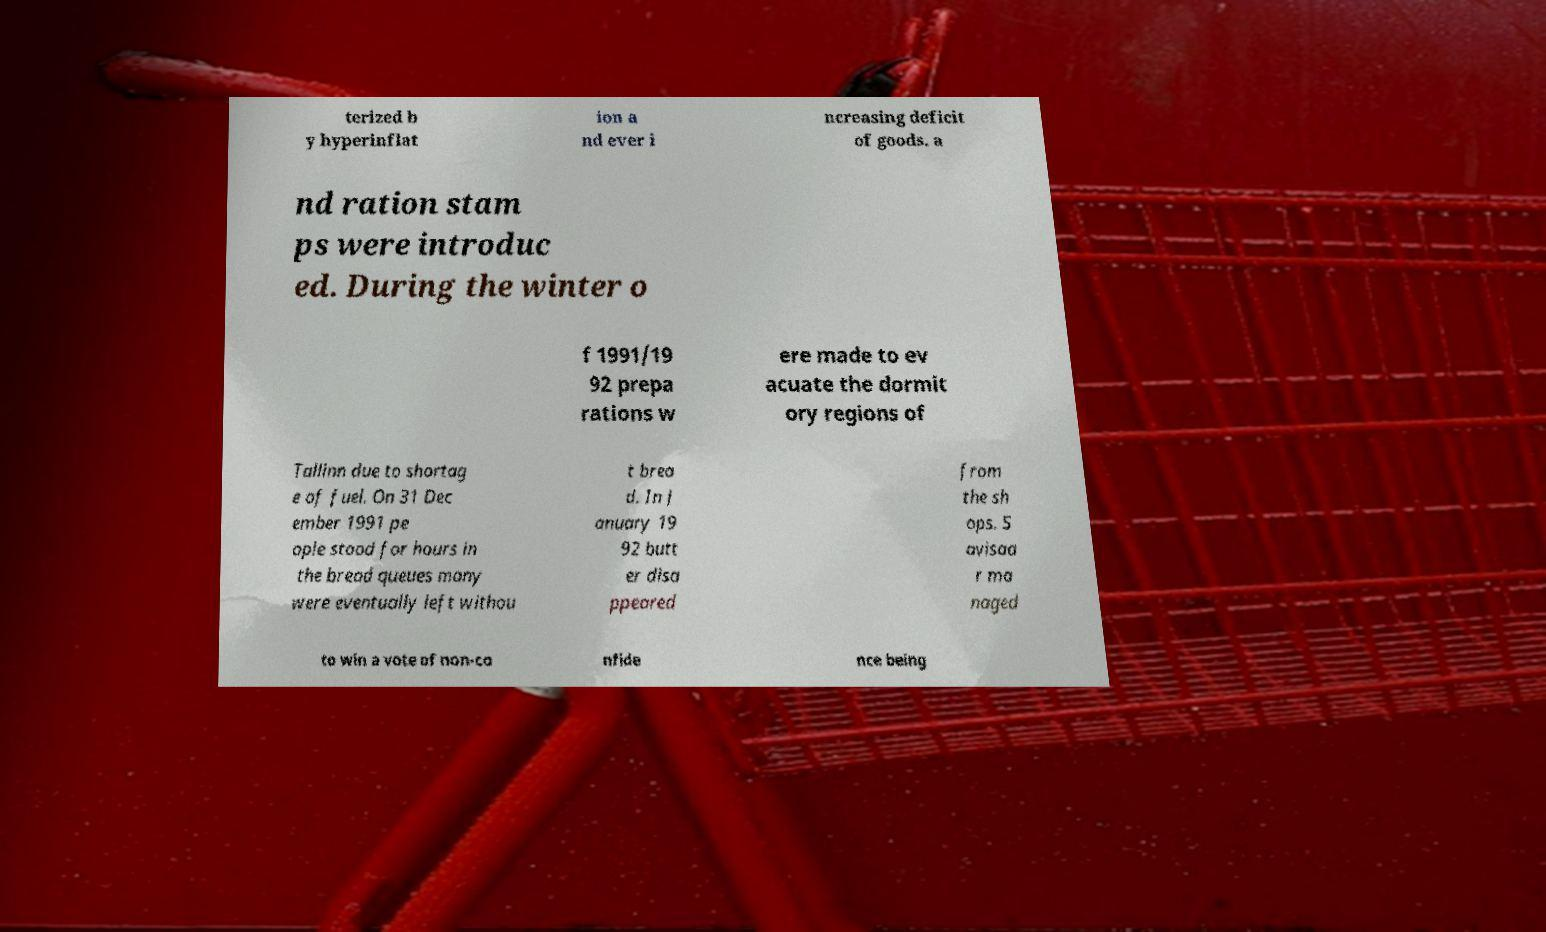Can you accurately transcribe the text from the provided image for me? terized b y hyperinflat ion a nd ever i ncreasing deficit of goods. a nd ration stam ps were introduc ed. During the winter o f 1991/19 92 prepa rations w ere made to ev acuate the dormit ory regions of Tallinn due to shortag e of fuel. On 31 Dec ember 1991 pe ople stood for hours in the bread queues many were eventually left withou t brea d. In J anuary 19 92 butt er disa ppeared from the sh ops. S avisaa r ma naged to win a vote of non-co nfide nce being 